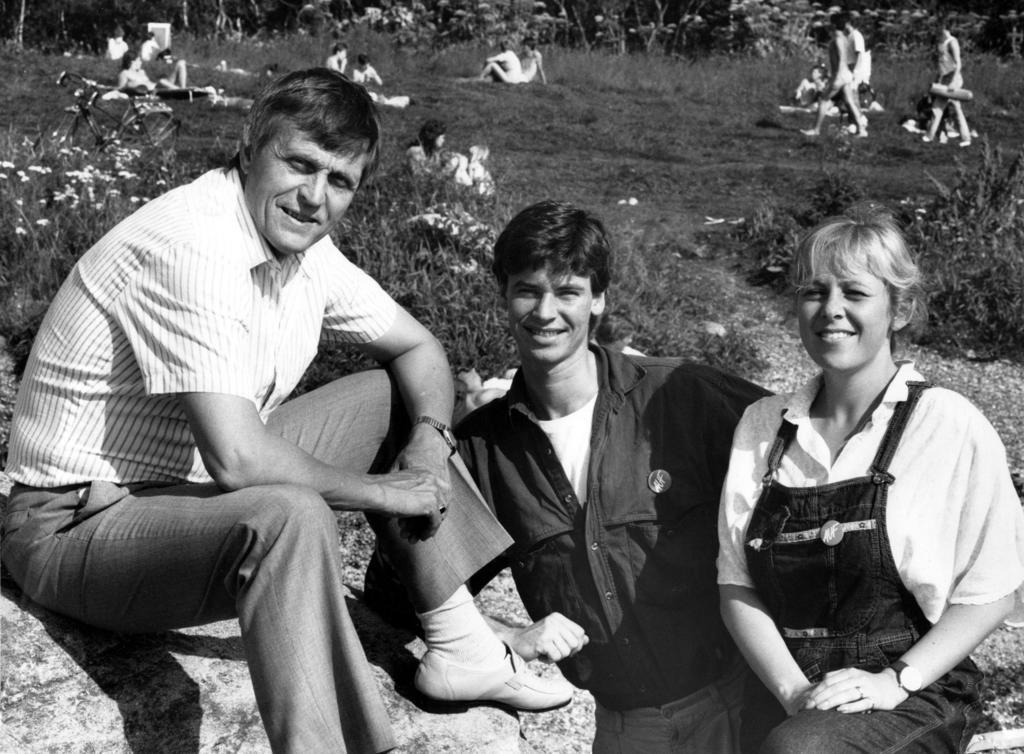What is the color scheme of the image? The image is black and white. How many persons are sitting on the rock in the image? There are three persons sitting on a rock in the image. What type of vegetation is behind the three persons? There is grass behind the three persons. Can you describe the people behind the three persons? There are groups of people behind the three persons. What mode of transportation is visible in the image? There is a bicycle visible in the image. What can be seen in the background of the image? Trees are present in the background of the image. How does the dust settle on the bicycle in the image? There is no dust present in the image, as it is black and white and does not depict any dust particles. 